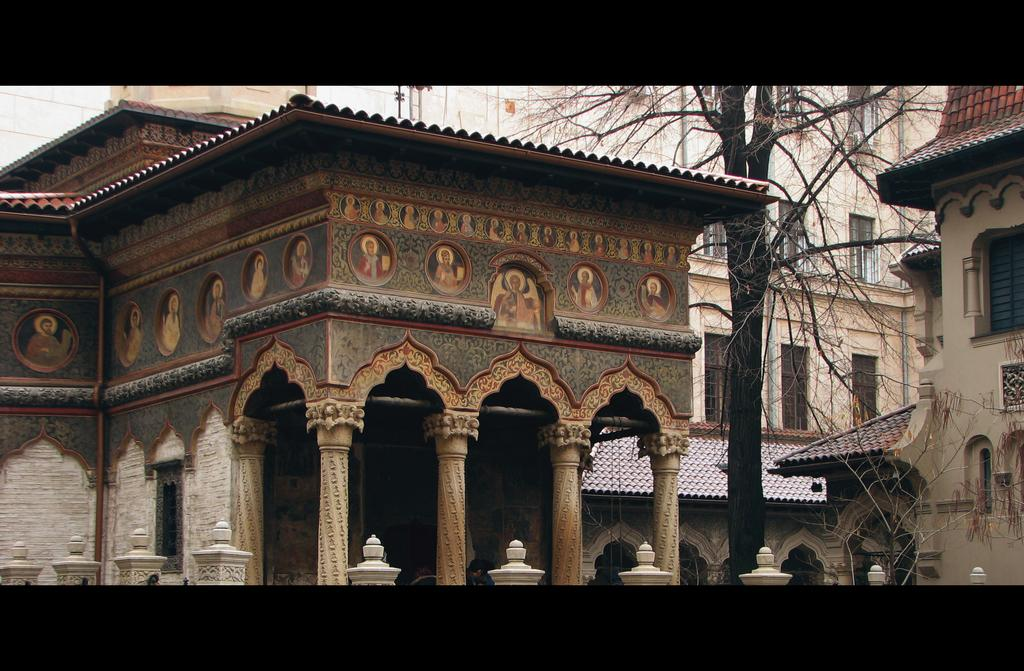What is located in the center of the image? There are buildings, trees, and pillars in the center of the image. What is on the left side of the image? There is a building on the left side of the image. What is featured on the building on the left side? There is a painting on the building on the left side. Can you see a spoon in the painting on the building on the left side? There is no spoon mentioned or visible in the painting on the building on the left side. Is there a maid standing next to the trees in the center of the image? There is no mention of a maid or any person in the image; it only features buildings, trees, and pillars. 